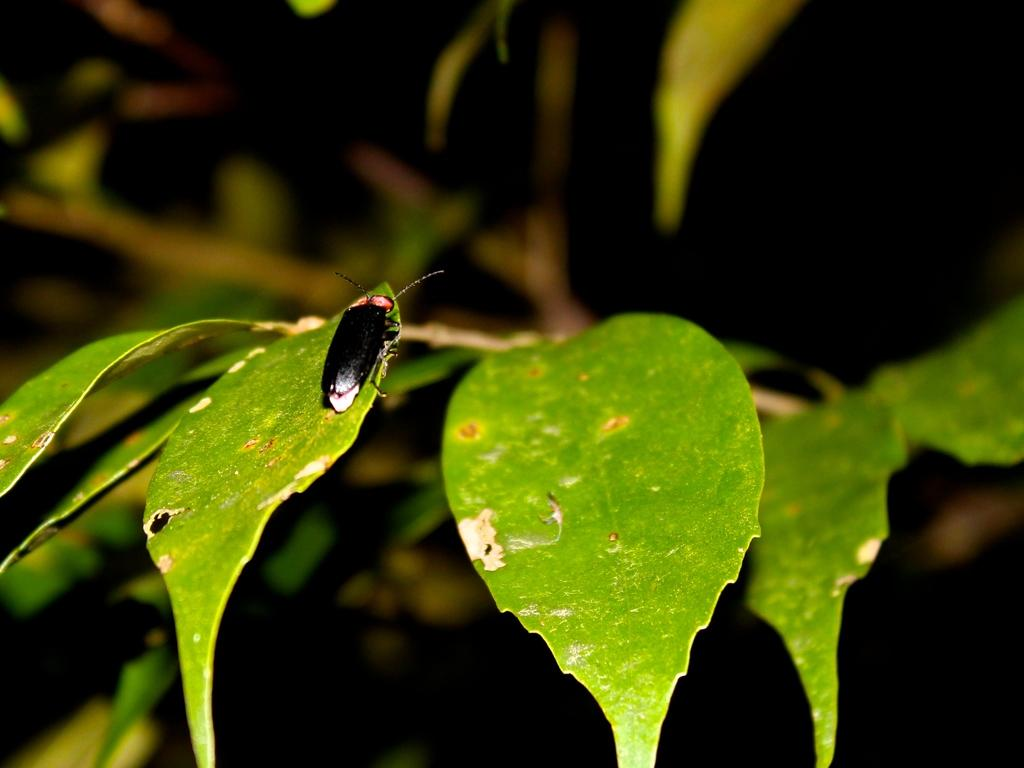What is on the leaf in the image? There is an insect on a leaf in the image. What can be seen in the background of the image? There is a tree branch visible in the background of the image. What type of tub is visible in the image? There is no tub present in the image; it features an insect on a leaf and a tree branch in the background. 